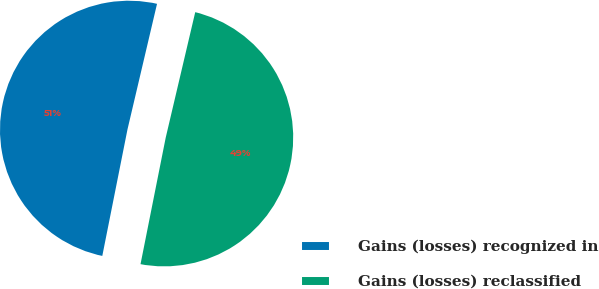Convert chart. <chart><loc_0><loc_0><loc_500><loc_500><pie_chart><fcel>Gains (losses) recognized in<fcel>Gains (losses) reclassified<nl><fcel>50.55%<fcel>49.45%<nl></chart> 